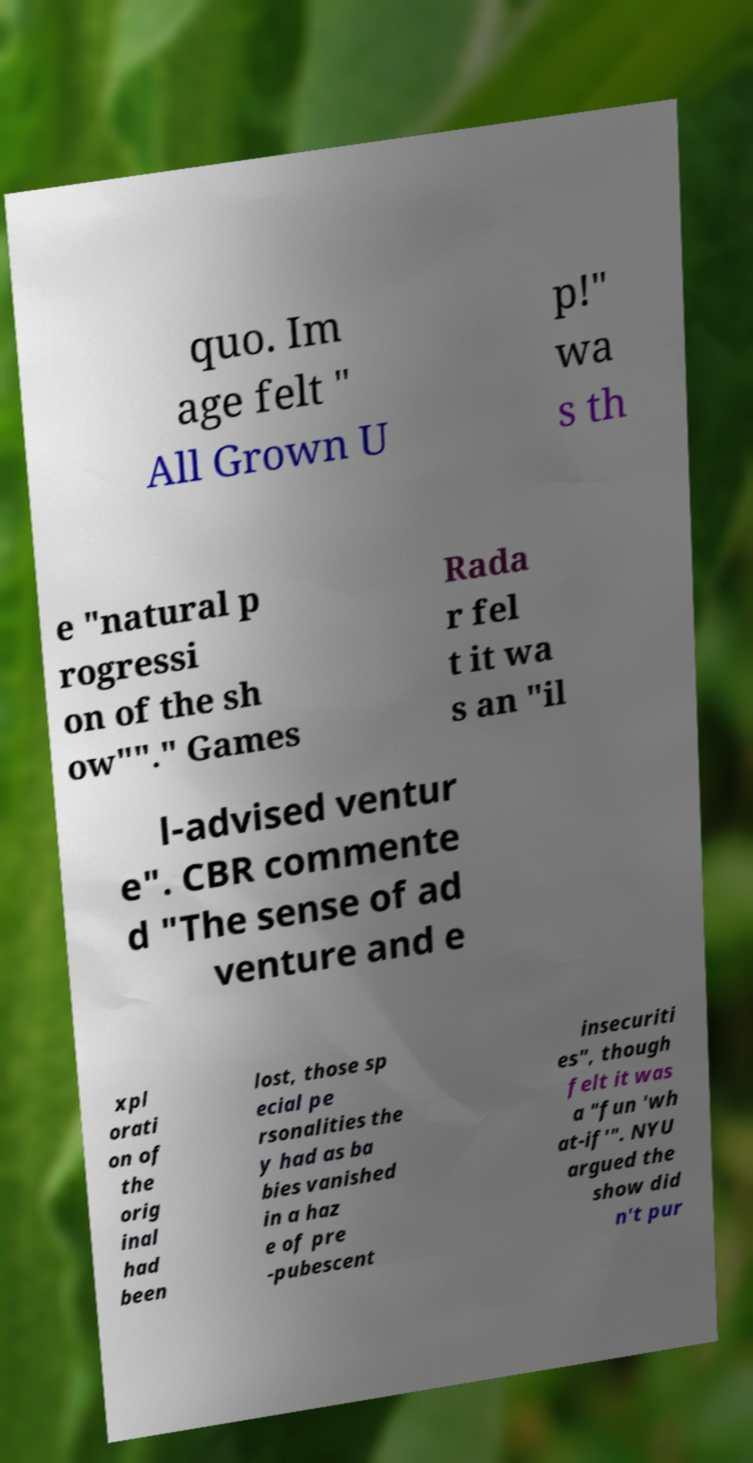Can you read and provide the text displayed in the image?This photo seems to have some interesting text. Can you extract and type it out for me? quo. Im age felt " All Grown U p!" wa s th e "natural p rogressi on of the sh ow""." Games Rada r fel t it wa s an "il l-advised ventur e". CBR commente d "The sense of ad venture and e xpl orati on of the orig inal had been lost, those sp ecial pe rsonalities the y had as ba bies vanished in a haz e of pre -pubescent insecuriti es", though felt it was a "fun 'wh at-if'". NYU argued the show did n't pur 